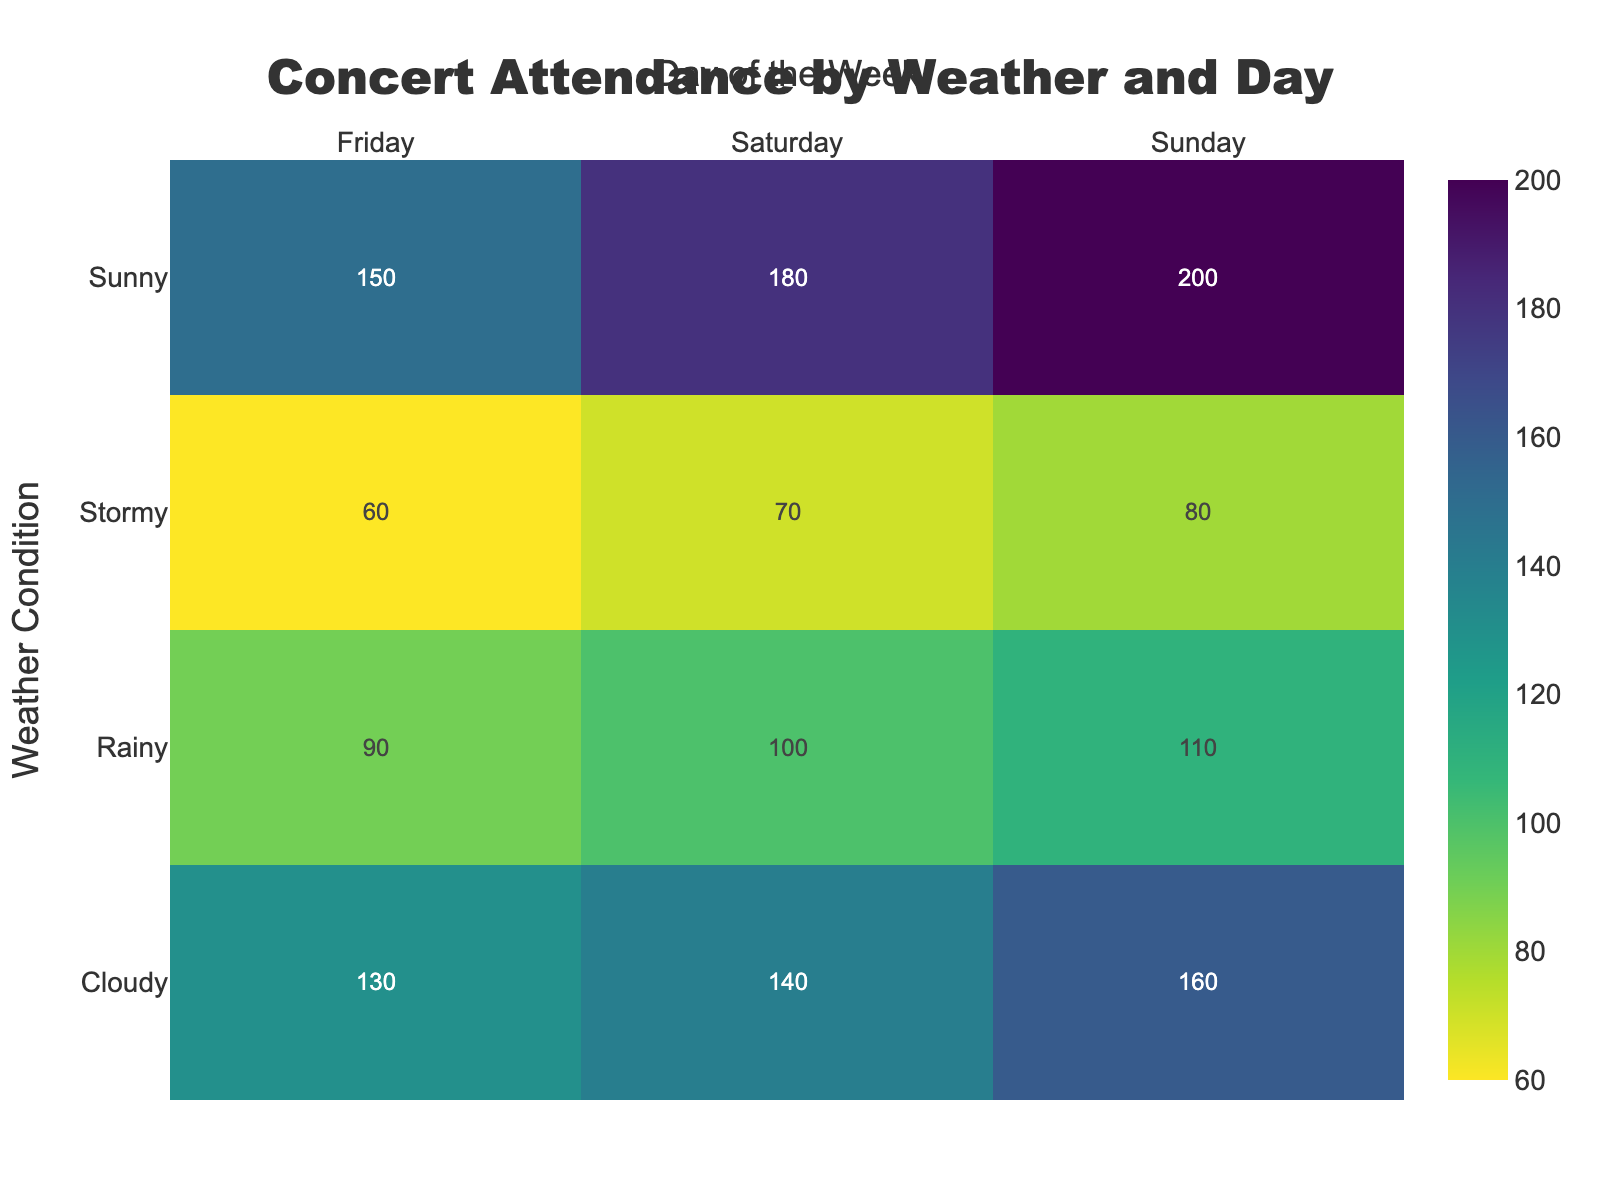what is the title of the heatmap? The title is located at the top center of the figure and visually represents the overall theme of the heatmap. It indicates that the data pertains to concert attendance segmented by weather conditions and days of the week.
Answer: Concert Attendance by Weather and Day Which weather condition had the highest concert attendance on Sunday? To determine this, look at the row labeled "Sunday" and check for the highest value in the cells under this row. The cell with the highest number gives the specific weather condition with the highest attendance.
Answer: Sunny How does the concert attendance on a rainy Saturday compare with a sunny Saturday? To compare these two values, find the cell corresponding to "Rainy" row and "Saturday" column, and the cell for "Sunny" row and "Saturday" column. Subtract the value of the rainy Saturday from the sunny Saturday.
Answer: 80 higher in Sunny (180 vs. 100) What is the total concert attendance on Fridays irrespective of the weather condition? Add the values in the column corresponding to "Friday" for all weather conditions. The values are 150, 130, 90, and 60. Summing these gives the total attendance on Fridays.
Answer: 430 Which day and weather condition combination had the lowest concert attendance? Identify the lowest value within the heatmap and note its corresponding row and column to ascertain the specific combination of day and weather condition.
Answer: Stormy Friday On which day does attendance increase the most from Stormy to Sunny conditions? Calculate the difference in attendance between "Stormy" and "Sunny" for each day of the week by subtracting Stormy value from Sunny value for Friday, Saturday, and Sunday respectively. Identify the highest difference.
Answer: Sunday (120 increase) Is there a noticeable trend in concert attendance related to weather conditions? Observe the attendance values across different weather conditions while keeping days of the week constant. Notice whether there's an increase or decrease in attendance as weather changes from Sunny to Stormy.
Answer: Decreases as weather worsens Which weather condition shows the highest average concert attendance across different days? Calculate the average attendance for each weather condition by summing the values for each day and dividing by the number of days (3). Compare these averages to determine the highest.
Answer: Sunny (176.67 average) How much higher is attendance on a sunny Sunday compared to a cloudy Sunday? Find the attendance values for both "Sunny" and "Cloudy" on Sunday and subtract the latter from the former to determine the difference.
Answer: 40 higher (200 vs. 160) What pattern of attendance can be observed during weekends compared to weekdays across different weather conditions? Compare the attendance values for Saturdays and Sundays (weekends) against attendance values for Fridays (weekdays). Look for any distinct differences or patterns emerging from the heatmap.
Answer: Weekends generally have higher attendance 